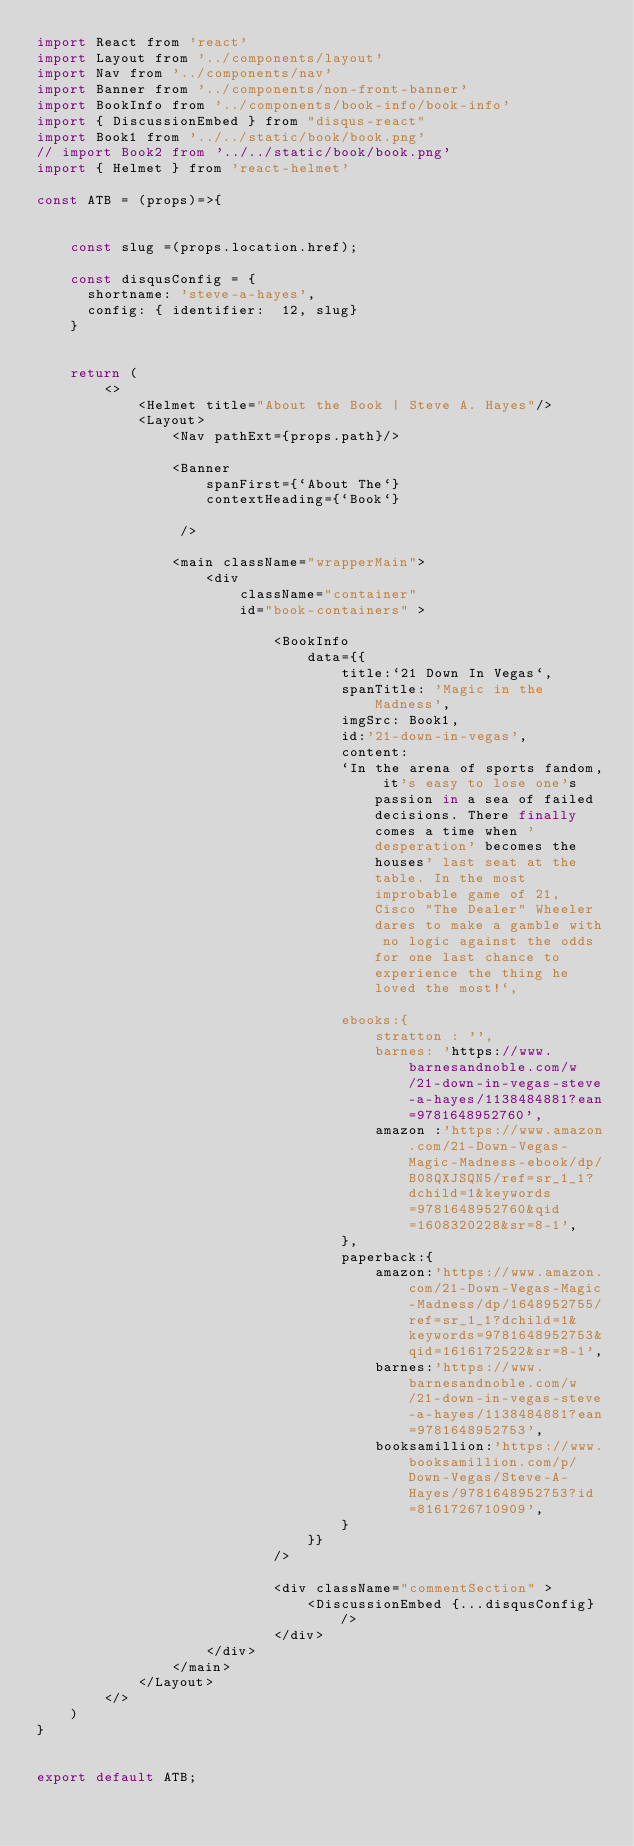<code> <loc_0><loc_0><loc_500><loc_500><_JavaScript_>import React from 'react'
import Layout from '../components/layout'
import Nav from '../components/nav'
import Banner from '../components/non-front-banner'
import BookInfo from '../components/book-info/book-info'
import { DiscussionEmbed } from "disqus-react"
import Book1 from '../../static/book/book.png'
// import Book2 from '../../static/book/book.png'
import { Helmet } from 'react-helmet'

const ATB = (props)=>{


    const slug =(props.location.href);
    
	const disqusConfig = {
	  shortname: 'steve-a-hayes',
	  config: { identifier:  12, slug}
    }
    

	return (
		<>
            <Helmet title="About the Book | Steve A. Hayes"/>
		 	<Layout>
		 		<Nav pathExt={props.path}/>
            
		 		<Banner
                    spanFirst={`About The`}
                    contextHeading={`Book`}
                 
                 />

                <main className="wrapperMain">
                    <div 
                        className="container"
                        id="book-containers" >

                            <BookInfo
                                data={{
                                    title:`21 Down In Vegas`,
                                    spanTitle: 'Magic in the Madness',
                                    imgSrc: Book1,
                                    id:'21-down-in-vegas',
                                    content:
                                    `In the arena of sports fandom, it's easy to lose one's passion in a sea of failed decisions. There finally comes a time when 'desperation' becomes the houses' last seat at the table. In the most improbable game of 21, Cisco "The Dealer" Wheeler dares to make a gamble with no logic against the odds for one last chance to experience the thing he loved the most!`,
                                    
                                    ebooks:{
                                        stratton : '',
                                        barnes: 'https://www.barnesandnoble.com/w/21-down-in-vegas-steve-a-hayes/1138484881?ean=9781648952760',
                                        amazon :'https://www.amazon.com/21-Down-Vegas-Magic-Madness-ebook/dp/B08QXJSQN5/ref=sr_1_1?dchild=1&keywords=9781648952760&qid=1608320228&sr=8-1', 
                                    },
                                    paperback:{
                                        amazon:'https://www.amazon.com/21-Down-Vegas-Magic-Madness/dp/1648952755/ref=sr_1_1?dchild=1&keywords=9781648952753&qid=1616172522&sr=8-1',
                                        barnes:'https://www.barnesandnoble.com/w/21-down-in-vegas-steve-a-hayes/1138484881?ean=9781648952753',
                                        booksamillion:'https://www.booksamillion.com/p/Down-Vegas/Steve-A-Hayes/9781648952753?id=8161726710909',
                                    }
                                }}
                            />

                            <div className="commentSection" >
                                <DiscussionEmbed {...disqusConfig} />
                            </div>
                    </div>	
                </main>
		 	</Layout>
		</>
	)
}


export default ATB;</code> 